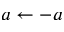<formula> <loc_0><loc_0><loc_500><loc_500>a \gets - a</formula> 